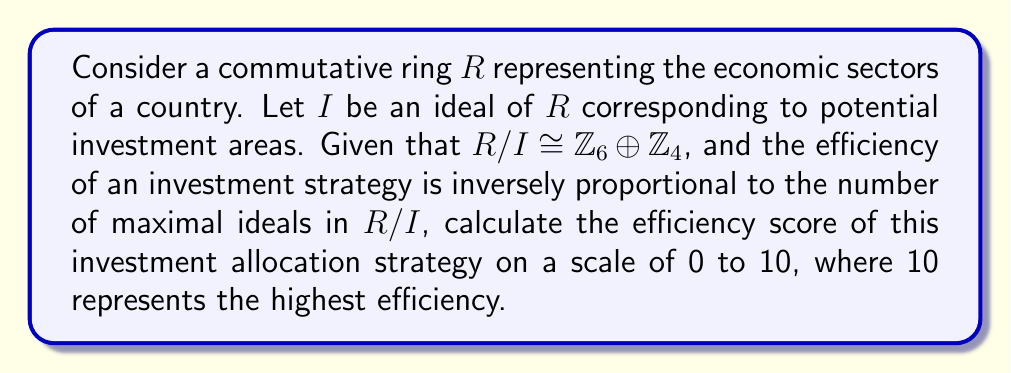Help me with this question. To solve this problem, we need to follow these steps:

1) First, we need to understand the structure of $R/I$. We are given that $R/I \cong \mathbb{Z}_6 \oplus \mathbb{Z}_4$.

2) Recall that in ring theory, the number of maximal ideals in a ring is equal to the number of simple factors in its decomposition into a direct sum of local rings.

3) To find the number of simple factors, we need to decompose $\mathbb{Z}_6$ and $\mathbb{Z}_4$ further:

   $\mathbb{Z}_6 \cong \mathbb{Z}_2 \oplus \mathbb{Z}_3$ (by the Chinese Remainder Theorem)
   $\mathbb{Z}_4$ is already a local ring

4) Therefore, $R/I \cong \mathbb{Z}_2 \oplus \mathbb{Z}_3 \oplus \mathbb{Z}_4$

5) This decomposition shows that $R/I$ has 3 simple factors, which means it has 3 maximal ideals.

6) Given that the efficiency is inversely proportional to the number of maximal ideals, we can set up an inverse proportion:

   $\text{Efficiency} \propto \frac{1}{\text{Number of maximal ideals}}$

7) To scale this to a 0-10 range, we can use the formula:

   $\text{Efficiency score} = 10 \cdot \frac{1}{\text{Number of maximal ideals}}$

8) Plugging in our value:

   $\text{Efficiency score} = 10 \cdot \frac{1}{3} \approx 3.33$

Therefore, the efficiency score of this investment allocation strategy is approximately 3.33 out of 10.
Answer: The efficiency score of the investment allocation strategy is approximately $3.33$ out of 10. 